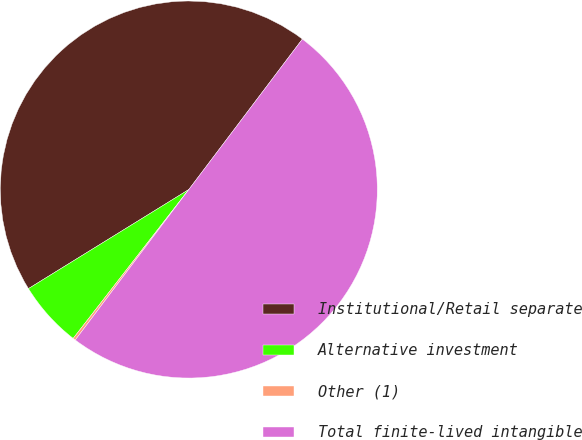Convert chart to OTSL. <chart><loc_0><loc_0><loc_500><loc_500><pie_chart><fcel>Institutional/Retail separate<fcel>Alternative investment<fcel>Other (1)<fcel>Total finite-lived intangible<nl><fcel>44.1%<fcel>5.68%<fcel>0.22%<fcel>50.0%<nl></chart> 